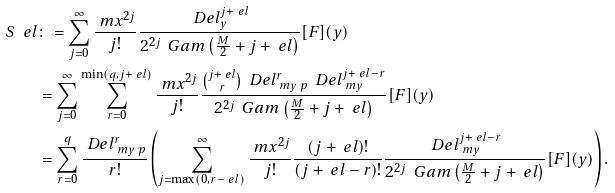<formula> <loc_0><loc_0><loc_500><loc_500>S _ { \ } e l & \colon = \sum _ { j = 0 } ^ { \infty } \frac { \ m { x } ^ { 2 j } } { j ! } \frac { \ D e l _ { y } ^ { j + \ e l } } { 2 ^ { 2 j } \, \ G a m \left ( \frac { M } { 2 } + j + \ e l \right ) } [ F ] ( { y } ) \\ & = \sum _ { j = 0 } ^ { \infty } \sum _ { r = 0 } ^ { \min ( q , j + \ e l ) } \frac { \ m { x } ^ { 2 j } } { j ! } \frac { \binom { j + \ e l } { r } \, \ D e l _ { \ m { y } \ p } ^ { r } \, \ D e l _ { \ m { y } } ^ { j + \ e l - r } } { 2 ^ { 2 j } \, \ G a m \left ( \frac { M } { 2 } + j + \ e l \right ) } [ F ] ( { y } ) \\ & = \sum _ { r = 0 } ^ { q } \frac { \ D e l _ { \ m { y } \ p } ^ { r } } { r ! } \left ( \sum _ { j = \max ( 0 , r - \ e l ) } ^ { \infty } \frac { \ m { x } ^ { 2 j } } { j ! } \frac { ( j + \ e l ) ! } { ( j + \ e l - r ) ! } \frac { \ D e l _ { \ m { y } } ^ { j + \ e l - r } } { 2 ^ { 2 j } \, \ G a m \left ( \frac { M } { 2 } + j + \ e l \right ) } [ F ] ( { y } ) \right ) .</formula> 